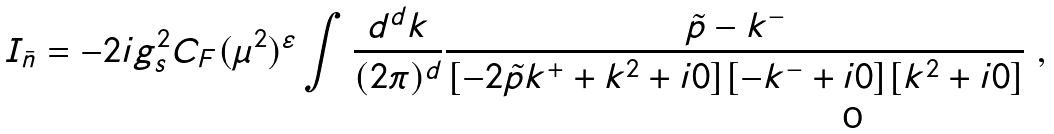<formula> <loc_0><loc_0><loc_500><loc_500>I _ { \bar { n } } = - 2 i g _ { s } ^ { 2 } C _ { F } ( \mu ^ { 2 } ) ^ { \varepsilon } \int \frac { d ^ { d } k } { ( 2 \pi ) ^ { d } } \frac { { \tilde { p } } - k ^ { - } } { [ - 2 { \tilde { p } } k ^ { + } + k ^ { 2 } + i 0 ] [ - k ^ { - } + i 0 ] [ k ^ { 2 } + i 0 ] } \ ,</formula> 